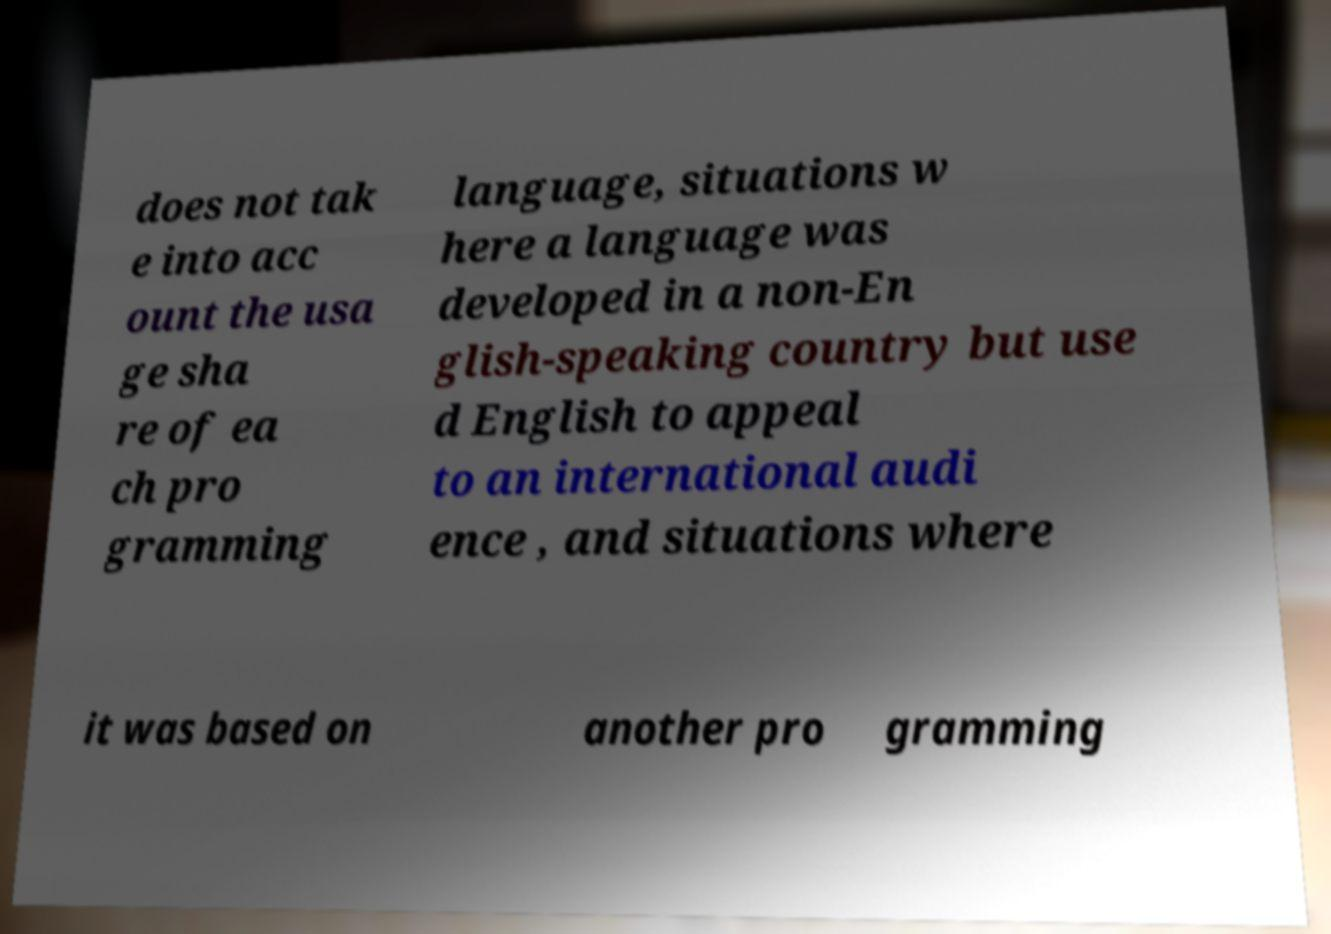For documentation purposes, I need the text within this image transcribed. Could you provide that? does not tak e into acc ount the usa ge sha re of ea ch pro gramming language, situations w here a language was developed in a non-En glish-speaking country but use d English to appeal to an international audi ence , and situations where it was based on another pro gramming 